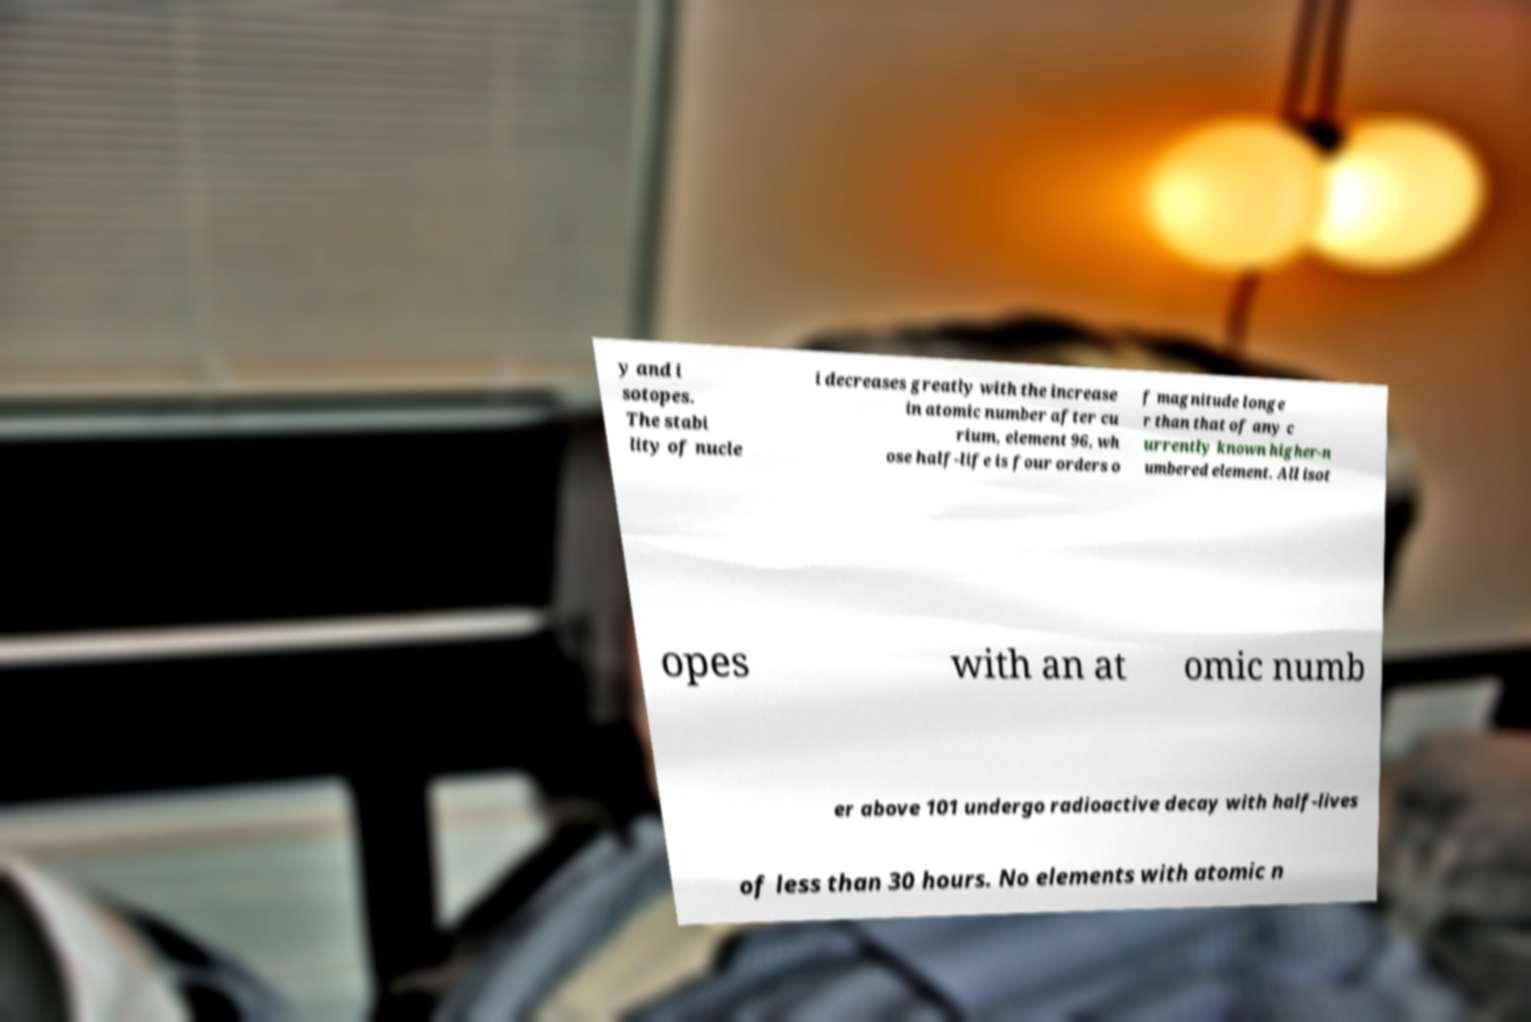Could you assist in decoding the text presented in this image and type it out clearly? y and i sotopes. The stabi lity of nucle i decreases greatly with the increase in atomic number after cu rium, element 96, wh ose half-life is four orders o f magnitude longe r than that of any c urrently known higher-n umbered element. All isot opes with an at omic numb er above 101 undergo radioactive decay with half-lives of less than 30 hours. No elements with atomic n 